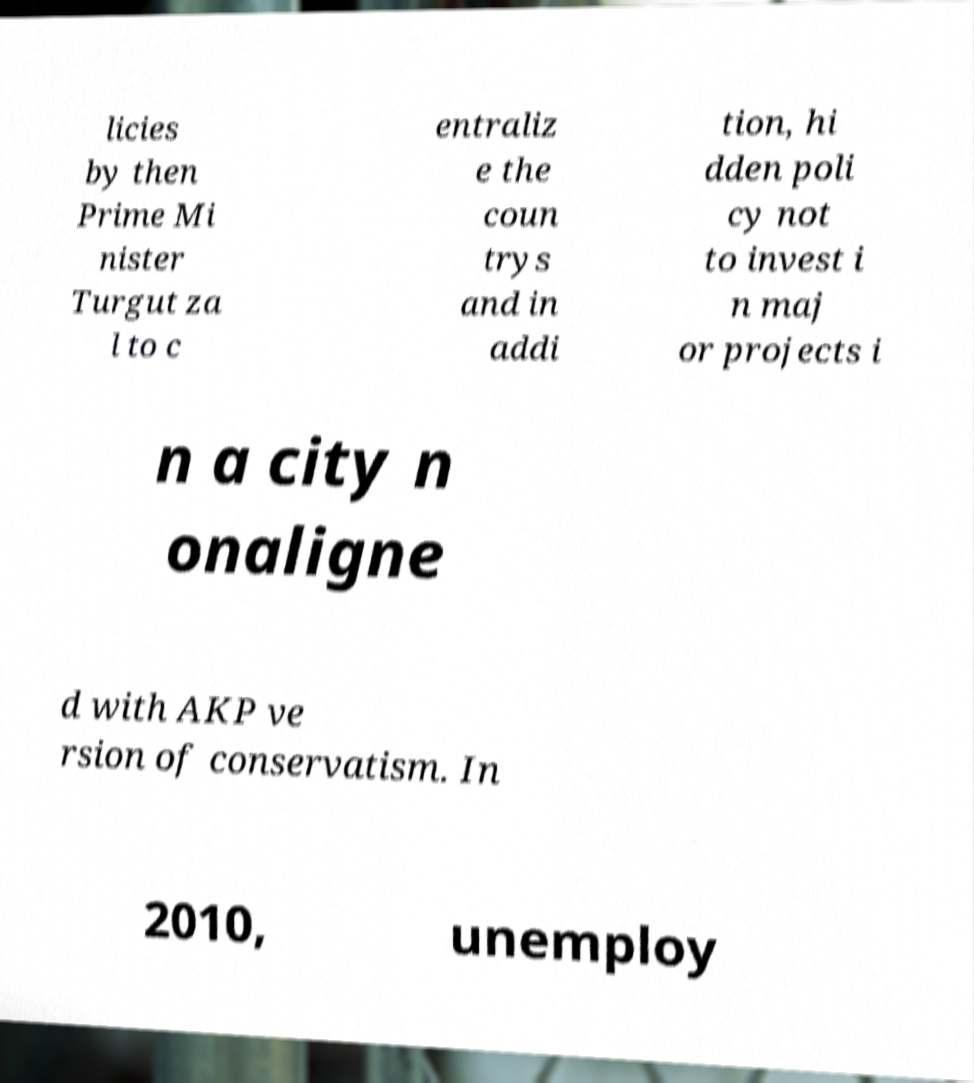Please read and relay the text visible in this image. What does it say? licies by then Prime Mi nister Turgut za l to c entraliz e the coun trys and in addi tion, hi dden poli cy not to invest i n maj or projects i n a city n onaligne d with AKP ve rsion of conservatism. In 2010, unemploy 